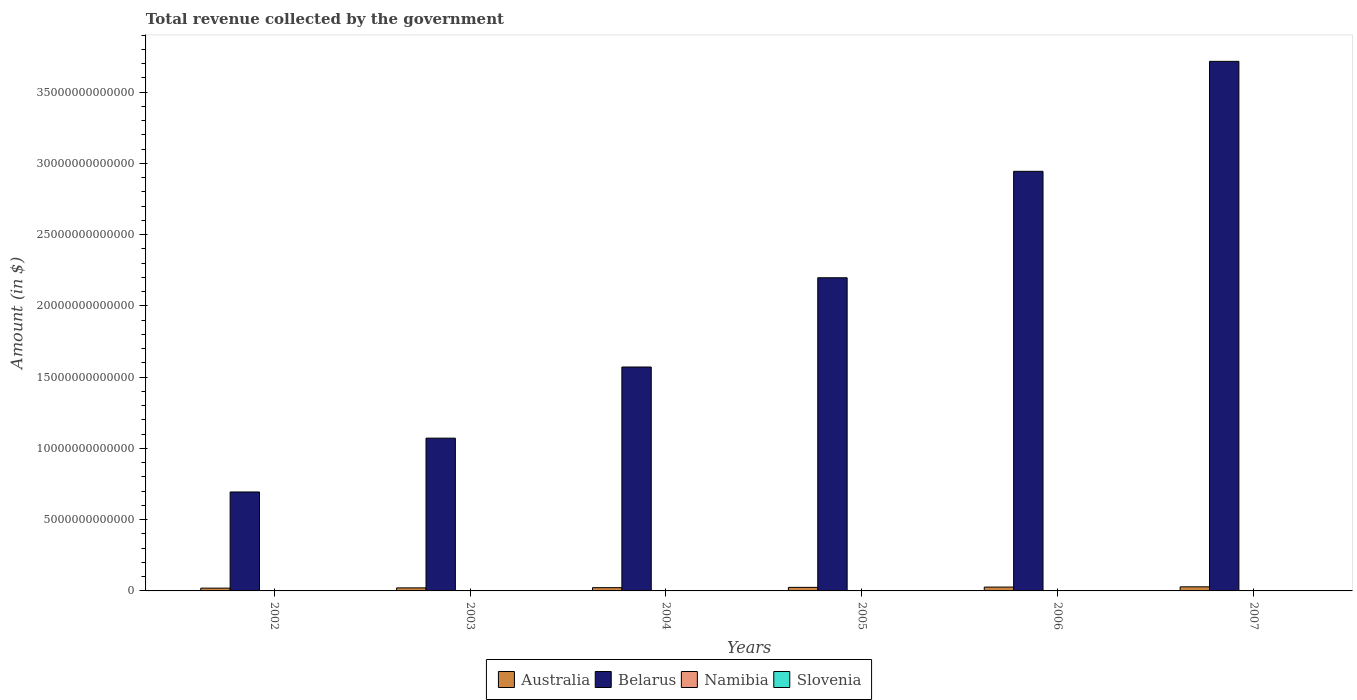Are the number of bars per tick equal to the number of legend labels?
Your answer should be compact. Yes. How many bars are there on the 1st tick from the left?
Give a very brief answer. 4. What is the label of the 2nd group of bars from the left?
Offer a terse response. 2003. What is the total revenue collected by the government in Namibia in 2004?
Give a very brief answer. 1.13e+1. Across all years, what is the maximum total revenue collected by the government in Belarus?
Make the answer very short. 3.72e+13. Across all years, what is the minimum total revenue collected by the government in Namibia?
Give a very brief answer. 9.71e+09. In which year was the total revenue collected by the government in Australia maximum?
Offer a very short reply. 2007. In which year was the total revenue collected by the government in Slovenia minimum?
Provide a short and direct response. 2002. What is the total total revenue collected by the government in Slovenia in the graph?
Make the answer very short. 6.49e+1. What is the difference between the total revenue collected by the government in Belarus in 2002 and that in 2003?
Keep it short and to the point. -3.78e+12. What is the difference between the total revenue collected by the government in Belarus in 2002 and the total revenue collected by the government in Slovenia in 2004?
Your answer should be very brief. 6.93e+12. What is the average total revenue collected by the government in Belarus per year?
Offer a terse response. 2.03e+13. In the year 2004, what is the difference between the total revenue collected by the government in Belarus and total revenue collected by the government in Slovenia?
Make the answer very short. 1.57e+13. In how many years, is the total revenue collected by the government in Slovenia greater than 36000000000000 $?
Your answer should be compact. 0. What is the ratio of the total revenue collected by the government in Namibia in 2002 to that in 2006?
Make the answer very short. 0.6. Is the difference between the total revenue collected by the government in Belarus in 2005 and 2006 greater than the difference between the total revenue collected by the government in Slovenia in 2005 and 2006?
Provide a short and direct response. No. What is the difference between the highest and the second highest total revenue collected by the government in Belarus?
Keep it short and to the point. 7.72e+12. What is the difference between the highest and the lowest total revenue collected by the government in Namibia?
Provide a short and direct response. 8.44e+09. In how many years, is the total revenue collected by the government in Belarus greater than the average total revenue collected by the government in Belarus taken over all years?
Offer a very short reply. 3. Is the sum of the total revenue collected by the government in Slovenia in 2004 and 2006 greater than the maximum total revenue collected by the government in Namibia across all years?
Ensure brevity in your answer.  Yes. What does the 1st bar from the left in 2004 represents?
Offer a very short reply. Australia. What does the 1st bar from the right in 2004 represents?
Give a very brief answer. Slovenia. How many bars are there?
Provide a succinct answer. 24. Are all the bars in the graph horizontal?
Your answer should be very brief. No. What is the difference between two consecutive major ticks on the Y-axis?
Your response must be concise. 5.00e+12. Are the values on the major ticks of Y-axis written in scientific E-notation?
Offer a very short reply. No. How many legend labels are there?
Your response must be concise. 4. What is the title of the graph?
Your answer should be very brief. Total revenue collected by the government. What is the label or title of the Y-axis?
Your answer should be very brief. Amount (in $). What is the Amount (in $) in Australia in 2002?
Keep it short and to the point. 1.96e+11. What is the Amount (in $) in Belarus in 2002?
Give a very brief answer. 6.94e+12. What is the Amount (in $) of Namibia in 2002?
Make the answer very short. 1.04e+1. What is the Amount (in $) of Slovenia in 2002?
Provide a short and direct response. 8.65e+09. What is the Amount (in $) in Australia in 2003?
Make the answer very short. 2.13e+11. What is the Amount (in $) of Belarus in 2003?
Keep it short and to the point. 1.07e+13. What is the Amount (in $) of Namibia in 2003?
Keep it short and to the point. 9.71e+09. What is the Amount (in $) in Slovenia in 2003?
Your answer should be compact. 9.88e+09. What is the Amount (in $) in Australia in 2004?
Keep it short and to the point. 2.29e+11. What is the Amount (in $) in Belarus in 2004?
Provide a short and direct response. 1.57e+13. What is the Amount (in $) in Namibia in 2004?
Provide a short and direct response. 1.13e+1. What is the Amount (in $) of Slovenia in 2004?
Your answer should be compact. 1.05e+1. What is the Amount (in $) in Australia in 2005?
Your answer should be very brief. 2.50e+11. What is the Amount (in $) in Belarus in 2005?
Ensure brevity in your answer.  2.20e+13. What is the Amount (in $) in Namibia in 2005?
Ensure brevity in your answer.  1.30e+1. What is the Amount (in $) of Slovenia in 2005?
Provide a short and direct response. 1.11e+1. What is the Amount (in $) of Australia in 2006?
Provide a short and direct response. 2.69e+11. What is the Amount (in $) of Belarus in 2006?
Offer a very short reply. 2.94e+13. What is the Amount (in $) of Namibia in 2006?
Make the answer very short. 1.75e+1. What is the Amount (in $) of Slovenia in 2006?
Give a very brief answer. 1.20e+1. What is the Amount (in $) of Australia in 2007?
Give a very brief answer. 2.87e+11. What is the Amount (in $) in Belarus in 2007?
Your answer should be compact. 3.72e+13. What is the Amount (in $) in Namibia in 2007?
Offer a very short reply. 1.82e+1. What is the Amount (in $) of Slovenia in 2007?
Keep it short and to the point. 1.27e+1. Across all years, what is the maximum Amount (in $) in Australia?
Your answer should be compact. 2.87e+11. Across all years, what is the maximum Amount (in $) in Belarus?
Ensure brevity in your answer.  3.72e+13. Across all years, what is the maximum Amount (in $) of Namibia?
Provide a succinct answer. 1.82e+1. Across all years, what is the maximum Amount (in $) in Slovenia?
Your response must be concise. 1.27e+1. Across all years, what is the minimum Amount (in $) of Australia?
Keep it short and to the point. 1.96e+11. Across all years, what is the minimum Amount (in $) in Belarus?
Your answer should be compact. 6.94e+12. Across all years, what is the minimum Amount (in $) in Namibia?
Provide a short and direct response. 9.71e+09. Across all years, what is the minimum Amount (in $) in Slovenia?
Give a very brief answer. 8.65e+09. What is the total Amount (in $) in Australia in the graph?
Ensure brevity in your answer.  1.44e+12. What is the total Amount (in $) of Belarus in the graph?
Ensure brevity in your answer.  1.22e+14. What is the total Amount (in $) of Namibia in the graph?
Give a very brief answer. 8.01e+1. What is the total Amount (in $) of Slovenia in the graph?
Ensure brevity in your answer.  6.49e+1. What is the difference between the Amount (in $) of Australia in 2002 and that in 2003?
Offer a very short reply. -1.74e+1. What is the difference between the Amount (in $) of Belarus in 2002 and that in 2003?
Make the answer very short. -3.78e+12. What is the difference between the Amount (in $) of Namibia in 2002 and that in 2003?
Offer a terse response. 7.29e+08. What is the difference between the Amount (in $) in Slovenia in 2002 and that in 2003?
Provide a succinct answer. -1.23e+09. What is the difference between the Amount (in $) in Australia in 2002 and that in 2004?
Your response must be concise. -3.31e+1. What is the difference between the Amount (in $) of Belarus in 2002 and that in 2004?
Keep it short and to the point. -8.77e+12. What is the difference between the Amount (in $) of Namibia in 2002 and that in 2004?
Keep it short and to the point. -8.26e+08. What is the difference between the Amount (in $) in Slovenia in 2002 and that in 2004?
Make the answer very short. -1.85e+09. What is the difference between the Amount (in $) in Australia in 2002 and that in 2005?
Offer a very short reply. -5.36e+1. What is the difference between the Amount (in $) in Belarus in 2002 and that in 2005?
Provide a succinct answer. -1.50e+13. What is the difference between the Amount (in $) of Namibia in 2002 and that in 2005?
Offer a terse response. -2.60e+09. What is the difference between the Amount (in $) in Slovenia in 2002 and that in 2005?
Offer a terse response. -2.48e+09. What is the difference between the Amount (in $) of Australia in 2002 and that in 2006?
Offer a terse response. -7.30e+1. What is the difference between the Amount (in $) in Belarus in 2002 and that in 2006?
Your answer should be compact. -2.25e+13. What is the difference between the Amount (in $) of Namibia in 2002 and that in 2006?
Provide a short and direct response. -7.08e+09. What is the difference between the Amount (in $) of Slovenia in 2002 and that in 2006?
Give a very brief answer. -3.30e+09. What is the difference between the Amount (in $) in Australia in 2002 and that in 2007?
Offer a very short reply. -9.11e+1. What is the difference between the Amount (in $) in Belarus in 2002 and that in 2007?
Keep it short and to the point. -3.02e+13. What is the difference between the Amount (in $) in Namibia in 2002 and that in 2007?
Offer a very short reply. -7.72e+09. What is the difference between the Amount (in $) in Slovenia in 2002 and that in 2007?
Your answer should be compact. -4.09e+09. What is the difference between the Amount (in $) of Australia in 2003 and that in 2004?
Provide a succinct answer. -1.56e+1. What is the difference between the Amount (in $) of Belarus in 2003 and that in 2004?
Ensure brevity in your answer.  -4.99e+12. What is the difference between the Amount (in $) in Namibia in 2003 and that in 2004?
Provide a short and direct response. -1.56e+09. What is the difference between the Amount (in $) of Slovenia in 2003 and that in 2004?
Your response must be concise. -6.23e+08. What is the difference between the Amount (in $) in Australia in 2003 and that in 2005?
Provide a short and direct response. -3.62e+1. What is the difference between the Amount (in $) in Belarus in 2003 and that in 2005?
Provide a short and direct response. -1.13e+13. What is the difference between the Amount (in $) of Namibia in 2003 and that in 2005?
Offer a very short reply. -3.32e+09. What is the difference between the Amount (in $) of Slovenia in 2003 and that in 2005?
Offer a very short reply. -1.24e+09. What is the difference between the Amount (in $) in Australia in 2003 and that in 2006?
Give a very brief answer. -5.56e+1. What is the difference between the Amount (in $) of Belarus in 2003 and that in 2006?
Your response must be concise. -1.87e+13. What is the difference between the Amount (in $) in Namibia in 2003 and that in 2006?
Ensure brevity in your answer.  -7.81e+09. What is the difference between the Amount (in $) in Slovenia in 2003 and that in 2006?
Make the answer very short. -2.07e+09. What is the difference between the Amount (in $) in Australia in 2003 and that in 2007?
Your answer should be compact. -7.37e+1. What is the difference between the Amount (in $) of Belarus in 2003 and that in 2007?
Offer a very short reply. -2.64e+13. What is the difference between the Amount (in $) in Namibia in 2003 and that in 2007?
Offer a terse response. -8.44e+09. What is the difference between the Amount (in $) of Slovenia in 2003 and that in 2007?
Ensure brevity in your answer.  -2.86e+09. What is the difference between the Amount (in $) of Australia in 2004 and that in 2005?
Give a very brief answer. -2.05e+1. What is the difference between the Amount (in $) of Belarus in 2004 and that in 2005?
Keep it short and to the point. -6.26e+12. What is the difference between the Amount (in $) of Namibia in 2004 and that in 2005?
Keep it short and to the point. -1.77e+09. What is the difference between the Amount (in $) of Slovenia in 2004 and that in 2005?
Make the answer very short. -6.21e+08. What is the difference between the Amount (in $) in Australia in 2004 and that in 2006?
Give a very brief answer. -4.00e+1. What is the difference between the Amount (in $) of Belarus in 2004 and that in 2006?
Provide a succinct answer. -1.37e+13. What is the difference between the Amount (in $) in Namibia in 2004 and that in 2006?
Your answer should be compact. -6.26e+09. What is the difference between the Amount (in $) in Slovenia in 2004 and that in 2006?
Provide a short and direct response. -1.45e+09. What is the difference between the Amount (in $) of Australia in 2004 and that in 2007?
Your response must be concise. -5.81e+1. What is the difference between the Amount (in $) of Belarus in 2004 and that in 2007?
Your answer should be very brief. -2.15e+13. What is the difference between the Amount (in $) in Namibia in 2004 and that in 2007?
Offer a very short reply. -6.89e+09. What is the difference between the Amount (in $) in Slovenia in 2004 and that in 2007?
Your answer should be very brief. -2.24e+09. What is the difference between the Amount (in $) of Australia in 2005 and that in 2006?
Your answer should be very brief. -1.95e+1. What is the difference between the Amount (in $) of Belarus in 2005 and that in 2006?
Ensure brevity in your answer.  -7.47e+12. What is the difference between the Amount (in $) in Namibia in 2005 and that in 2006?
Provide a succinct answer. -4.49e+09. What is the difference between the Amount (in $) of Slovenia in 2005 and that in 2006?
Your answer should be very brief. -8.28e+08. What is the difference between the Amount (in $) in Australia in 2005 and that in 2007?
Your answer should be very brief. -3.75e+1. What is the difference between the Amount (in $) in Belarus in 2005 and that in 2007?
Keep it short and to the point. -1.52e+13. What is the difference between the Amount (in $) in Namibia in 2005 and that in 2007?
Make the answer very short. -5.12e+09. What is the difference between the Amount (in $) in Slovenia in 2005 and that in 2007?
Give a very brief answer. -1.62e+09. What is the difference between the Amount (in $) of Australia in 2006 and that in 2007?
Offer a terse response. -1.81e+1. What is the difference between the Amount (in $) of Belarus in 2006 and that in 2007?
Ensure brevity in your answer.  -7.72e+12. What is the difference between the Amount (in $) of Namibia in 2006 and that in 2007?
Provide a short and direct response. -6.34e+08. What is the difference between the Amount (in $) of Slovenia in 2006 and that in 2007?
Provide a short and direct response. -7.89e+08. What is the difference between the Amount (in $) in Australia in 2002 and the Amount (in $) in Belarus in 2003?
Your answer should be compact. -1.05e+13. What is the difference between the Amount (in $) in Australia in 2002 and the Amount (in $) in Namibia in 2003?
Your answer should be compact. 1.86e+11. What is the difference between the Amount (in $) of Australia in 2002 and the Amount (in $) of Slovenia in 2003?
Your answer should be compact. 1.86e+11. What is the difference between the Amount (in $) of Belarus in 2002 and the Amount (in $) of Namibia in 2003?
Provide a succinct answer. 6.93e+12. What is the difference between the Amount (in $) of Belarus in 2002 and the Amount (in $) of Slovenia in 2003?
Your response must be concise. 6.93e+12. What is the difference between the Amount (in $) of Namibia in 2002 and the Amount (in $) of Slovenia in 2003?
Keep it short and to the point. 5.51e+08. What is the difference between the Amount (in $) in Australia in 2002 and the Amount (in $) in Belarus in 2004?
Your answer should be compact. -1.55e+13. What is the difference between the Amount (in $) in Australia in 2002 and the Amount (in $) in Namibia in 2004?
Provide a short and direct response. 1.85e+11. What is the difference between the Amount (in $) of Australia in 2002 and the Amount (in $) of Slovenia in 2004?
Your response must be concise. 1.86e+11. What is the difference between the Amount (in $) in Belarus in 2002 and the Amount (in $) in Namibia in 2004?
Your response must be concise. 6.93e+12. What is the difference between the Amount (in $) in Belarus in 2002 and the Amount (in $) in Slovenia in 2004?
Your answer should be compact. 6.93e+12. What is the difference between the Amount (in $) of Namibia in 2002 and the Amount (in $) of Slovenia in 2004?
Ensure brevity in your answer.  -7.25e+07. What is the difference between the Amount (in $) of Australia in 2002 and the Amount (in $) of Belarus in 2005?
Offer a very short reply. -2.18e+13. What is the difference between the Amount (in $) of Australia in 2002 and the Amount (in $) of Namibia in 2005?
Provide a succinct answer. 1.83e+11. What is the difference between the Amount (in $) of Australia in 2002 and the Amount (in $) of Slovenia in 2005?
Your answer should be very brief. 1.85e+11. What is the difference between the Amount (in $) in Belarus in 2002 and the Amount (in $) in Namibia in 2005?
Offer a very short reply. 6.93e+12. What is the difference between the Amount (in $) of Belarus in 2002 and the Amount (in $) of Slovenia in 2005?
Ensure brevity in your answer.  6.93e+12. What is the difference between the Amount (in $) in Namibia in 2002 and the Amount (in $) in Slovenia in 2005?
Provide a succinct answer. -6.93e+08. What is the difference between the Amount (in $) in Australia in 2002 and the Amount (in $) in Belarus in 2006?
Ensure brevity in your answer.  -2.93e+13. What is the difference between the Amount (in $) in Australia in 2002 and the Amount (in $) in Namibia in 2006?
Your answer should be compact. 1.79e+11. What is the difference between the Amount (in $) of Australia in 2002 and the Amount (in $) of Slovenia in 2006?
Provide a succinct answer. 1.84e+11. What is the difference between the Amount (in $) in Belarus in 2002 and the Amount (in $) in Namibia in 2006?
Provide a short and direct response. 6.93e+12. What is the difference between the Amount (in $) in Belarus in 2002 and the Amount (in $) in Slovenia in 2006?
Your answer should be compact. 6.93e+12. What is the difference between the Amount (in $) of Namibia in 2002 and the Amount (in $) of Slovenia in 2006?
Ensure brevity in your answer.  -1.52e+09. What is the difference between the Amount (in $) in Australia in 2002 and the Amount (in $) in Belarus in 2007?
Your answer should be very brief. -3.70e+13. What is the difference between the Amount (in $) of Australia in 2002 and the Amount (in $) of Namibia in 2007?
Ensure brevity in your answer.  1.78e+11. What is the difference between the Amount (in $) in Australia in 2002 and the Amount (in $) in Slovenia in 2007?
Your response must be concise. 1.83e+11. What is the difference between the Amount (in $) of Belarus in 2002 and the Amount (in $) of Namibia in 2007?
Provide a succinct answer. 6.93e+12. What is the difference between the Amount (in $) of Belarus in 2002 and the Amount (in $) of Slovenia in 2007?
Your response must be concise. 6.93e+12. What is the difference between the Amount (in $) in Namibia in 2002 and the Amount (in $) in Slovenia in 2007?
Make the answer very short. -2.31e+09. What is the difference between the Amount (in $) of Australia in 2003 and the Amount (in $) of Belarus in 2004?
Provide a short and direct response. -1.55e+13. What is the difference between the Amount (in $) of Australia in 2003 and the Amount (in $) of Namibia in 2004?
Give a very brief answer. 2.02e+11. What is the difference between the Amount (in $) in Australia in 2003 and the Amount (in $) in Slovenia in 2004?
Provide a short and direct response. 2.03e+11. What is the difference between the Amount (in $) of Belarus in 2003 and the Amount (in $) of Namibia in 2004?
Offer a very short reply. 1.07e+13. What is the difference between the Amount (in $) of Belarus in 2003 and the Amount (in $) of Slovenia in 2004?
Your answer should be compact. 1.07e+13. What is the difference between the Amount (in $) in Namibia in 2003 and the Amount (in $) in Slovenia in 2004?
Ensure brevity in your answer.  -8.01e+08. What is the difference between the Amount (in $) in Australia in 2003 and the Amount (in $) in Belarus in 2005?
Provide a short and direct response. -2.18e+13. What is the difference between the Amount (in $) of Australia in 2003 and the Amount (in $) of Namibia in 2005?
Offer a terse response. 2.00e+11. What is the difference between the Amount (in $) of Australia in 2003 and the Amount (in $) of Slovenia in 2005?
Give a very brief answer. 2.02e+11. What is the difference between the Amount (in $) in Belarus in 2003 and the Amount (in $) in Namibia in 2005?
Make the answer very short. 1.07e+13. What is the difference between the Amount (in $) in Belarus in 2003 and the Amount (in $) in Slovenia in 2005?
Offer a very short reply. 1.07e+13. What is the difference between the Amount (in $) in Namibia in 2003 and the Amount (in $) in Slovenia in 2005?
Your answer should be compact. -1.42e+09. What is the difference between the Amount (in $) of Australia in 2003 and the Amount (in $) of Belarus in 2006?
Ensure brevity in your answer.  -2.92e+13. What is the difference between the Amount (in $) in Australia in 2003 and the Amount (in $) in Namibia in 2006?
Make the answer very short. 1.96e+11. What is the difference between the Amount (in $) in Australia in 2003 and the Amount (in $) in Slovenia in 2006?
Keep it short and to the point. 2.02e+11. What is the difference between the Amount (in $) in Belarus in 2003 and the Amount (in $) in Namibia in 2006?
Offer a terse response. 1.07e+13. What is the difference between the Amount (in $) of Belarus in 2003 and the Amount (in $) of Slovenia in 2006?
Provide a short and direct response. 1.07e+13. What is the difference between the Amount (in $) of Namibia in 2003 and the Amount (in $) of Slovenia in 2006?
Keep it short and to the point. -2.25e+09. What is the difference between the Amount (in $) of Australia in 2003 and the Amount (in $) of Belarus in 2007?
Provide a succinct answer. -3.70e+13. What is the difference between the Amount (in $) in Australia in 2003 and the Amount (in $) in Namibia in 2007?
Offer a very short reply. 1.95e+11. What is the difference between the Amount (in $) in Australia in 2003 and the Amount (in $) in Slovenia in 2007?
Provide a short and direct response. 2.01e+11. What is the difference between the Amount (in $) of Belarus in 2003 and the Amount (in $) of Namibia in 2007?
Your response must be concise. 1.07e+13. What is the difference between the Amount (in $) in Belarus in 2003 and the Amount (in $) in Slovenia in 2007?
Provide a succinct answer. 1.07e+13. What is the difference between the Amount (in $) in Namibia in 2003 and the Amount (in $) in Slovenia in 2007?
Give a very brief answer. -3.04e+09. What is the difference between the Amount (in $) of Australia in 2004 and the Amount (in $) of Belarus in 2005?
Your answer should be very brief. -2.17e+13. What is the difference between the Amount (in $) in Australia in 2004 and the Amount (in $) in Namibia in 2005?
Make the answer very short. 2.16e+11. What is the difference between the Amount (in $) of Australia in 2004 and the Amount (in $) of Slovenia in 2005?
Make the answer very short. 2.18e+11. What is the difference between the Amount (in $) of Belarus in 2004 and the Amount (in $) of Namibia in 2005?
Your answer should be very brief. 1.57e+13. What is the difference between the Amount (in $) in Belarus in 2004 and the Amount (in $) in Slovenia in 2005?
Your response must be concise. 1.57e+13. What is the difference between the Amount (in $) of Namibia in 2004 and the Amount (in $) of Slovenia in 2005?
Make the answer very short. 1.33e+08. What is the difference between the Amount (in $) of Australia in 2004 and the Amount (in $) of Belarus in 2006?
Your answer should be very brief. -2.92e+13. What is the difference between the Amount (in $) of Australia in 2004 and the Amount (in $) of Namibia in 2006?
Offer a very short reply. 2.12e+11. What is the difference between the Amount (in $) in Australia in 2004 and the Amount (in $) in Slovenia in 2006?
Your answer should be compact. 2.17e+11. What is the difference between the Amount (in $) in Belarus in 2004 and the Amount (in $) in Namibia in 2006?
Ensure brevity in your answer.  1.57e+13. What is the difference between the Amount (in $) in Belarus in 2004 and the Amount (in $) in Slovenia in 2006?
Offer a very short reply. 1.57e+13. What is the difference between the Amount (in $) in Namibia in 2004 and the Amount (in $) in Slovenia in 2006?
Keep it short and to the point. -6.95e+08. What is the difference between the Amount (in $) in Australia in 2004 and the Amount (in $) in Belarus in 2007?
Make the answer very short. -3.69e+13. What is the difference between the Amount (in $) of Australia in 2004 and the Amount (in $) of Namibia in 2007?
Give a very brief answer. 2.11e+11. What is the difference between the Amount (in $) in Australia in 2004 and the Amount (in $) in Slovenia in 2007?
Provide a short and direct response. 2.16e+11. What is the difference between the Amount (in $) in Belarus in 2004 and the Amount (in $) in Namibia in 2007?
Provide a succinct answer. 1.57e+13. What is the difference between the Amount (in $) in Belarus in 2004 and the Amount (in $) in Slovenia in 2007?
Give a very brief answer. 1.57e+13. What is the difference between the Amount (in $) of Namibia in 2004 and the Amount (in $) of Slovenia in 2007?
Make the answer very short. -1.48e+09. What is the difference between the Amount (in $) of Australia in 2005 and the Amount (in $) of Belarus in 2006?
Give a very brief answer. -2.92e+13. What is the difference between the Amount (in $) in Australia in 2005 and the Amount (in $) in Namibia in 2006?
Ensure brevity in your answer.  2.32e+11. What is the difference between the Amount (in $) of Australia in 2005 and the Amount (in $) of Slovenia in 2006?
Make the answer very short. 2.38e+11. What is the difference between the Amount (in $) in Belarus in 2005 and the Amount (in $) in Namibia in 2006?
Offer a very short reply. 2.20e+13. What is the difference between the Amount (in $) in Belarus in 2005 and the Amount (in $) in Slovenia in 2006?
Keep it short and to the point. 2.20e+13. What is the difference between the Amount (in $) in Namibia in 2005 and the Amount (in $) in Slovenia in 2006?
Offer a very short reply. 1.07e+09. What is the difference between the Amount (in $) of Australia in 2005 and the Amount (in $) of Belarus in 2007?
Give a very brief answer. -3.69e+13. What is the difference between the Amount (in $) of Australia in 2005 and the Amount (in $) of Namibia in 2007?
Your answer should be compact. 2.32e+11. What is the difference between the Amount (in $) in Australia in 2005 and the Amount (in $) in Slovenia in 2007?
Offer a terse response. 2.37e+11. What is the difference between the Amount (in $) in Belarus in 2005 and the Amount (in $) in Namibia in 2007?
Offer a terse response. 2.20e+13. What is the difference between the Amount (in $) of Belarus in 2005 and the Amount (in $) of Slovenia in 2007?
Provide a short and direct response. 2.20e+13. What is the difference between the Amount (in $) in Namibia in 2005 and the Amount (in $) in Slovenia in 2007?
Offer a very short reply. 2.86e+08. What is the difference between the Amount (in $) of Australia in 2006 and the Amount (in $) of Belarus in 2007?
Provide a short and direct response. -3.69e+13. What is the difference between the Amount (in $) of Australia in 2006 and the Amount (in $) of Namibia in 2007?
Give a very brief answer. 2.51e+11. What is the difference between the Amount (in $) of Australia in 2006 and the Amount (in $) of Slovenia in 2007?
Offer a very short reply. 2.56e+11. What is the difference between the Amount (in $) in Belarus in 2006 and the Amount (in $) in Namibia in 2007?
Make the answer very short. 2.94e+13. What is the difference between the Amount (in $) of Belarus in 2006 and the Amount (in $) of Slovenia in 2007?
Make the answer very short. 2.94e+13. What is the difference between the Amount (in $) in Namibia in 2006 and the Amount (in $) in Slovenia in 2007?
Keep it short and to the point. 4.77e+09. What is the average Amount (in $) in Australia per year?
Offer a terse response. 2.41e+11. What is the average Amount (in $) of Belarus per year?
Keep it short and to the point. 2.03e+13. What is the average Amount (in $) of Namibia per year?
Keep it short and to the point. 1.33e+1. What is the average Amount (in $) of Slovenia per year?
Give a very brief answer. 1.08e+1. In the year 2002, what is the difference between the Amount (in $) of Australia and Amount (in $) of Belarus?
Your response must be concise. -6.75e+12. In the year 2002, what is the difference between the Amount (in $) of Australia and Amount (in $) of Namibia?
Give a very brief answer. 1.86e+11. In the year 2002, what is the difference between the Amount (in $) of Australia and Amount (in $) of Slovenia?
Your response must be concise. 1.87e+11. In the year 2002, what is the difference between the Amount (in $) of Belarus and Amount (in $) of Namibia?
Give a very brief answer. 6.93e+12. In the year 2002, what is the difference between the Amount (in $) of Belarus and Amount (in $) of Slovenia?
Ensure brevity in your answer.  6.94e+12. In the year 2002, what is the difference between the Amount (in $) in Namibia and Amount (in $) in Slovenia?
Provide a short and direct response. 1.78e+09. In the year 2003, what is the difference between the Amount (in $) of Australia and Amount (in $) of Belarus?
Offer a terse response. -1.05e+13. In the year 2003, what is the difference between the Amount (in $) of Australia and Amount (in $) of Namibia?
Your answer should be very brief. 2.04e+11. In the year 2003, what is the difference between the Amount (in $) in Australia and Amount (in $) in Slovenia?
Ensure brevity in your answer.  2.04e+11. In the year 2003, what is the difference between the Amount (in $) in Belarus and Amount (in $) in Namibia?
Provide a short and direct response. 1.07e+13. In the year 2003, what is the difference between the Amount (in $) in Belarus and Amount (in $) in Slovenia?
Offer a very short reply. 1.07e+13. In the year 2003, what is the difference between the Amount (in $) of Namibia and Amount (in $) of Slovenia?
Your answer should be compact. -1.78e+08. In the year 2004, what is the difference between the Amount (in $) in Australia and Amount (in $) in Belarus?
Your answer should be compact. -1.55e+13. In the year 2004, what is the difference between the Amount (in $) of Australia and Amount (in $) of Namibia?
Your answer should be compact. 2.18e+11. In the year 2004, what is the difference between the Amount (in $) of Australia and Amount (in $) of Slovenia?
Your answer should be very brief. 2.19e+11. In the year 2004, what is the difference between the Amount (in $) of Belarus and Amount (in $) of Namibia?
Offer a terse response. 1.57e+13. In the year 2004, what is the difference between the Amount (in $) in Belarus and Amount (in $) in Slovenia?
Offer a very short reply. 1.57e+13. In the year 2004, what is the difference between the Amount (in $) in Namibia and Amount (in $) in Slovenia?
Offer a very short reply. 7.54e+08. In the year 2005, what is the difference between the Amount (in $) in Australia and Amount (in $) in Belarus?
Ensure brevity in your answer.  -2.17e+13. In the year 2005, what is the difference between the Amount (in $) in Australia and Amount (in $) in Namibia?
Your answer should be very brief. 2.37e+11. In the year 2005, what is the difference between the Amount (in $) in Australia and Amount (in $) in Slovenia?
Provide a short and direct response. 2.39e+11. In the year 2005, what is the difference between the Amount (in $) in Belarus and Amount (in $) in Namibia?
Your response must be concise. 2.20e+13. In the year 2005, what is the difference between the Amount (in $) of Belarus and Amount (in $) of Slovenia?
Your answer should be compact. 2.20e+13. In the year 2005, what is the difference between the Amount (in $) in Namibia and Amount (in $) in Slovenia?
Your response must be concise. 1.90e+09. In the year 2006, what is the difference between the Amount (in $) of Australia and Amount (in $) of Belarus?
Your response must be concise. -2.92e+13. In the year 2006, what is the difference between the Amount (in $) in Australia and Amount (in $) in Namibia?
Your answer should be very brief. 2.52e+11. In the year 2006, what is the difference between the Amount (in $) in Australia and Amount (in $) in Slovenia?
Keep it short and to the point. 2.57e+11. In the year 2006, what is the difference between the Amount (in $) of Belarus and Amount (in $) of Namibia?
Give a very brief answer. 2.94e+13. In the year 2006, what is the difference between the Amount (in $) in Belarus and Amount (in $) in Slovenia?
Keep it short and to the point. 2.94e+13. In the year 2006, what is the difference between the Amount (in $) in Namibia and Amount (in $) in Slovenia?
Offer a terse response. 5.56e+09. In the year 2007, what is the difference between the Amount (in $) of Australia and Amount (in $) of Belarus?
Give a very brief answer. -3.69e+13. In the year 2007, what is the difference between the Amount (in $) in Australia and Amount (in $) in Namibia?
Offer a very short reply. 2.69e+11. In the year 2007, what is the difference between the Amount (in $) of Australia and Amount (in $) of Slovenia?
Provide a short and direct response. 2.74e+11. In the year 2007, what is the difference between the Amount (in $) in Belarus and Amount (in $) in Namibia?
Your response must be concise. 3.71e+13. In the year 2007, what is the difference between the Amount (in $) in Belarus and Amount (in $) in Slovenia?
Offer a terse response. 3.72e+13. In the year 2007, what is the difference between the Amount (in $) of Namibia and Amount (in $) of Slovenia?
Make the answer very short. 5.41e+09. What is the ratio of the Amount (in $) of Australia in 2002 to that in 2003?
Your answer should be compact. 0.92. What is the ratio of the Amount (in $) in Belarus in 2002 to that in 2003?
Your answer should be compact. 0.65. What is the ratio of the Amount (in $) of Namibia in 2002 to that in 2003?
Your answer should be very brief. 1.08. What is the ratio of the Amount (in $) of Slovenia in 2002 to that in 2003?
Your answer should be compact. 0.88. What is the ratio of the Amount (in $) of Australia in 2002 to that in 2004?
Your answer should be very brief. 0.86. What is the ratio of the Amount (in $) of Belarus in 2002 to that in 2004?
Provide a succinct answer. 0.44. What is the ratio of the Amount (in $) in Namibia in 2002 to that in 2004?
Make the answer very short. 0.93. What is the ratio of the Amount (in $) in Slovenia in 2002 to that in 2004?
Ensure brevity in your answer.  0.82. What is the ratio of the Amount (in $) of Australia in 2002 to that in 2005?
Ensure brevity in your answer.  0.79. What is the ratio of the Amount (in $) in Belarus in 2002 to that in 2005?
Provide a short and direct response. 0.32. What is the ratio of the Amount (in $) in Namibia in 2002 to that in 2005?
Offer a very short reply. 0.8. What is the ratio of the Amount (in $) in Slovenia in 2002 to that in 2005?
Ensure brevity in your answer.  0.78. What is the ratio of the Amount (in $) in Australia in 2002 to that in 2006?
Provide a short and direct response. 0.73. What is the ratio of the Amount (in $) in Belarus in 2002 to that in 2006?
Ensure brevity in your answer.  0.24. What is the ratio of the Amount (in $) in Namibia in 2002 to that in 2006?
Offer a terse response. 0.6. What is the ratio of the Amount (in $) of Slovenia in 2002 to that in 2006?
Your answer should be very brief. 0.72. What is the ratio of the Amount (in $) of Australia in 2002 to that in 2007?
Offer a terse response. 0.68. What is the ratio of the Amount (in $) of Belarus in 2002 to that in 2007?
Your answer should be very brief. 0.19. What is the ratio of the Amount (in $) in Namibia in 2002 to that in 2007?
Provide a short and direct response. 0.57. What is the ratio of the Amount (in $) in Slovenia in 2002 to that in 2007?
Ensure brevity in your answer.  0.68. What is the ratio of the Amount (in $) in Australia in 2003 to that in 2004?
Offer a terse response. 0.93. What is the ratio of the Amount (in $) in Belarus in 2003 to that in 2004?
Make the answer very short. 0.68. What is the ratio of the Amount (in $) of Namibia in 2003 to that in 2004?
Provide a short and direct response. 0.86. What is the ratio of the Amount (in $) in Slovenia in 2003 to that in 2004?
Provide a short and direct response. 0.94. What is the ratio of the Amount (in $) of Australia in 2003 to that in 2005?
Your answer should be very brief. 0.86. What is the ratio of the Amount (in $) in Belarus in 2003 to that in 2005?
Your answer should be compact. 0.49. What is the ratio of the Amount (in $) in Namibia in 2003 to that in 2005?
Your answer should be compact. 0.74. What is the ratio of the Amount (in $) of Slovenia in 2003 to that in 2005?
Ensure brevity in your answer.  0.89. What is the ratio of the Amount (in $) in Australia in 2003 to that in 2006?
Offer a terse response. 0.79. What is the ratio of the Amount (in $) in Belarus in 2003 to that in 2006?
Ensure brevity in your answer.  0.36. What is the ratio of the Amount (in $) of Namibia in 2003 to that in 2006?
Offer a very short reply. 0.55. What is the ratio of the Amount (in $) in Slovenia in 2003 to that in 2006?
Give a very brief answer. 0.83. What is the ratio of the Amount (in $) of Australia in 2003 to that in 2007?
Your answer should be compact. 0.74. What is the ratio of the Amount (in $) of Belarus in 2003 to that in 2007?
Offer a terse response. 0.29. What is the ratio of the Amount (in $) in Namibia in 2003 to that in 2007?
Ensure brevity in your answer.  0.53. What is the ratio of the Amount (in $) of Slovenia in 2003 to that in 2007?
Give a very brief answer. 0.78. What is the ratio of the Amount (in $) in Australia in 2004 to that in 2005?
Ensure brevity in your answer.  0.92. What is the ratio of the Amount (in $) of Belarus in 2004 to that in 2005?
Ensure brevity in your answer.  0.71. What is the ratio of the Amount (in $) in Namibia in 2004 to that in 2005?
Keep it short and to the point. 0.86. What is the ratio of the Amount (in $) in Slovenia in 2004 to that in 2005?
Keep it short and to the point. 0.94. What is the ratio of the Amount (in $) in Australia in 2004 to that in 2006?
Your answer should be very brief. 0.85. What is the ratio of the Amount (in $) in Belarus in 2004 to that in 2006?
Offer a very short reply. 0.53. What is the ratio of the Amount (in $) in Namibia in 2004 to that in 2006?
Provide a short and direct response. 0.64. What is the ratio of the Amount (in $) of Slovenia in 2004 to that in 2006?
Offer a terse response. 0.88. What is the ratio of the Amount (in $) in Australia in 2004 to that in 2007?
Your response must be concise. 0.8. What is the ratio of the Amount (in $) in Belarus in 2004 to that in 2007?
Offer a very short reply. 0.42. What is the ratio of the Amount (in $) of Namibia in 2004 to that in 2007?
Your response must be concise. 0.62. What is the ratio of the Amount (in $) in Slovenia in 2004 to that in 2007?
Make the answer very short. 0.82. What is the ratio of the Amount (in $) of Australia in 2005 to that in 2006?
Ensure brevity in your answer.  0.93. What is the ratio of the Amount (in $) in Belarus in 2005 to that in 2006?
Make the answer very short. 0.75. What is the ratio of the Amount (in $) of Namibia in 2005 to that in 2006?
Your answer should be compact. 0.74. What is the ratio of the Amount (in $) of Slovenia in 2005 to that in 2006?
Your answer should be compact. 0.93. What is the ratio of the Amount (in $) of Australia in 2005 to that in 2007?
Give a very brief answer. 0.87. What is the ratio of the Amount (in $) of Belarus in 2005 to that in 2007?
Give a very brief answer. 0.59. What is the ratio of the Amount (in $) in Namibia in 2005 to that in 2007?
Provide a succinct answer. 0.72. What is the ratio of the Amount (in $) in Slovenia in 2005 to that in 2007?
Offer a terse response. 0.87. What is the ratio of the Amount (in $) in Australia in 2006 to that in 2007?
Provide a succinct answer. 0.94. What is the ratio of the Amount (in $) of Belarus in 2006 to that in 2007?
Keep it short and to the point. 0.79. What is the ratio of the Amount (in $) in Namibia in 2006 to that in 2007?
Your response must be concise. 0.97. What is the ratio of the Amount (in $) in Slovenia in 2006 to that in 2007?
Ensure brevity in your answer.  0.94. What is the difference between the highest and the second highest Amount (in $) of Australia?
Ensure brevity in your answer.  1.81e+1. What is the difference between the highest and the second highest Amount (in $) of Belarus?
Provide a short and direct response. 7.72e+12. What is the difference between the highest and the second highest Amount (in $) in Namibia?
Keep it short and to the point. 6.34e+08. What is the difference between the highest and the second highest Amount (in $) in Slovenia?
Give a very brief answer. 7.89e+08. What is the difference between the highest and the lowest Amount (in $) of Australia?
Your answer should be compact. 9.11e+1. What is the difference between the highest and the lowest Amount (in $) of Belarus?
Your response must be concise. 3.02e+13. What is the difference between the highest and the lowest Amount (in $) in Namibia?
Give a very brief answer. 8.44e+09. What is the difference between the highest and the lowest Amount (in $) in Slovenia?
Provide a succinct answer. 4.09e+09. 